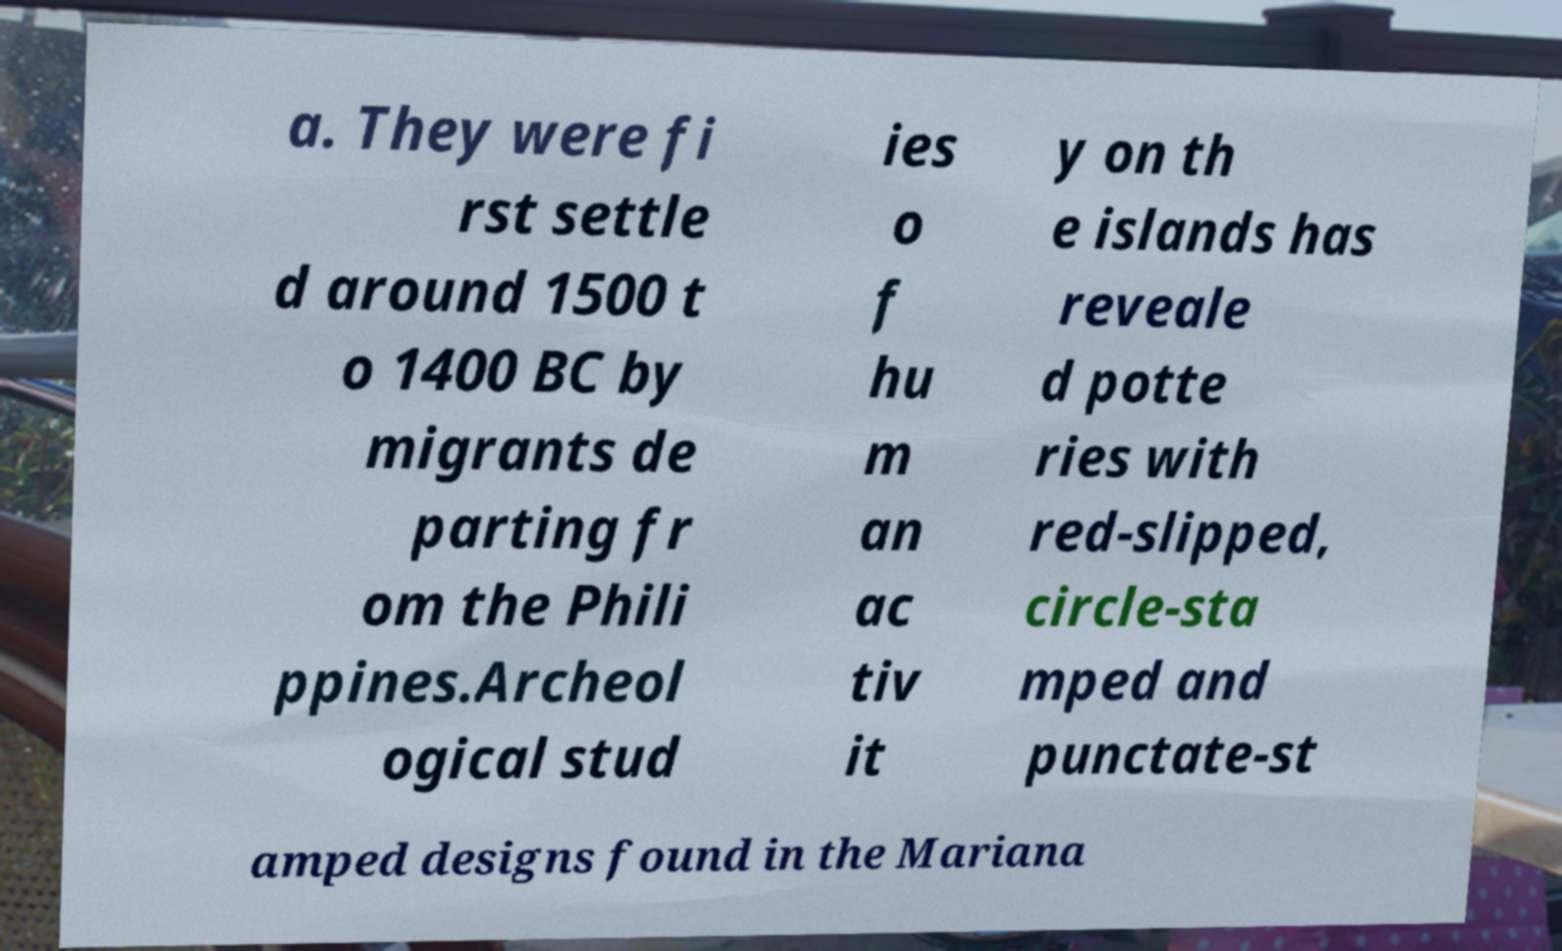There's text embedded in this image that I need extracted. Can you transcribe it verbatim? a. They were fi rst settle d around 1500 t o 1400 BC by migrants de parting fr om the Phili ppines.Archeol ogical stud ies o f hu m an ac tiv it y on th e islands has reveale d potte ries with red-slipped, circle-sta mped and punctate-st amped designs found in the Mariana 